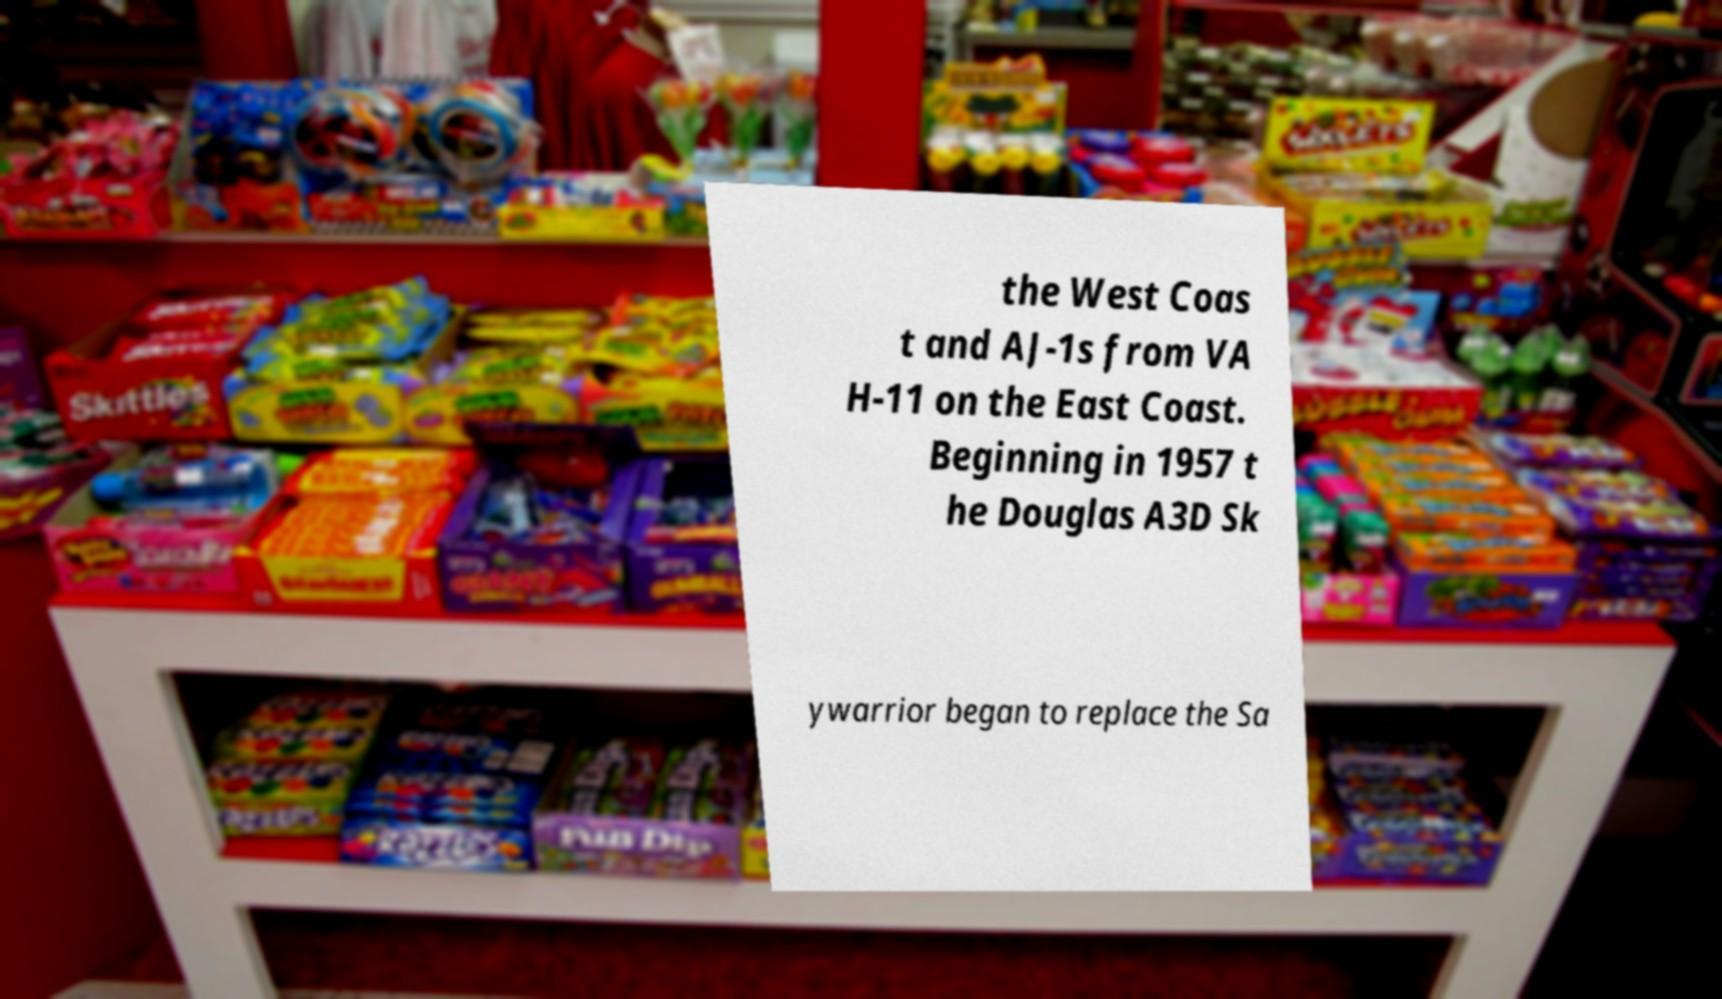Could you extract and type out the text from this image? the West Coas t and AJ-1s from VA H-11 on the East Coast. Beginning in 1957 t he Douglas A3D Sk ywarrior began to replace the Sa 